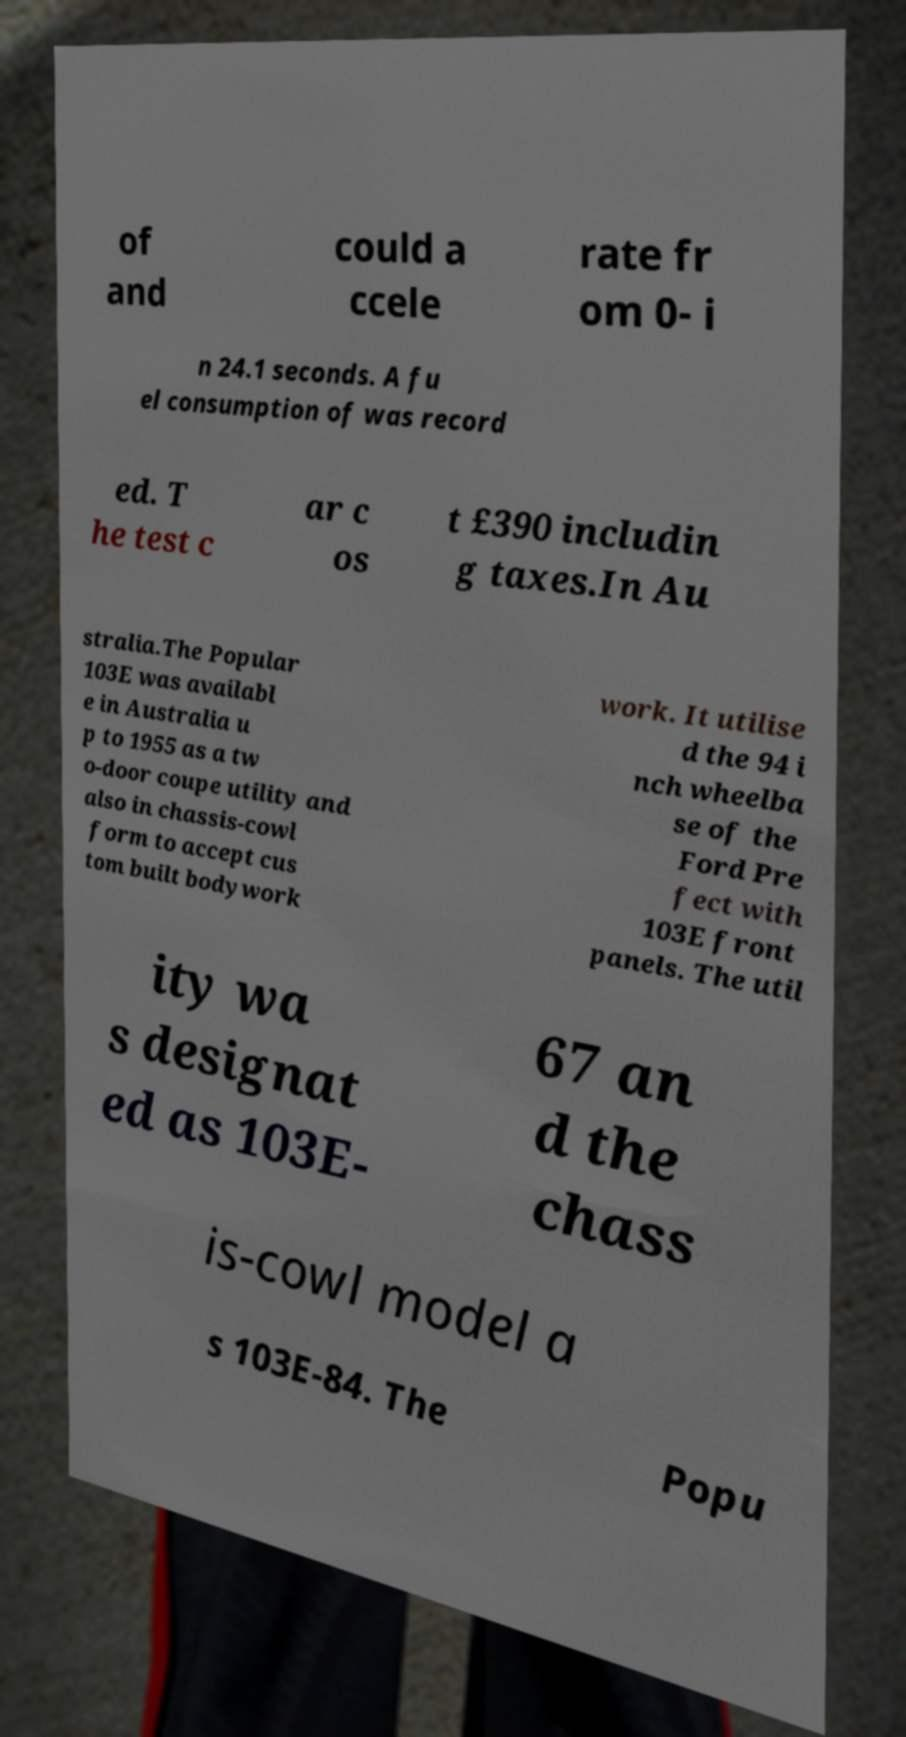I need the written content from this picture converted into text. Can you do that? of and could a ccele rate fr om 0- i n 24.1 seconds. A fu el consumption of was record ed. T he test c ar c os t £390 includin g taxes.In Au stralia.The Popular 103E was availabl e in Australia u p to 1955 as a tw o-door coupe utility and also in chassis-cowl form to accept cus tom built bodywork work. It utilise d the 94 i nch wheelba se of the Ford Pre fect with 103E front panels. The util ity wa s designat ed as 103E- 67 an d the chass is-cowl model a s 103E-84. The Popu 